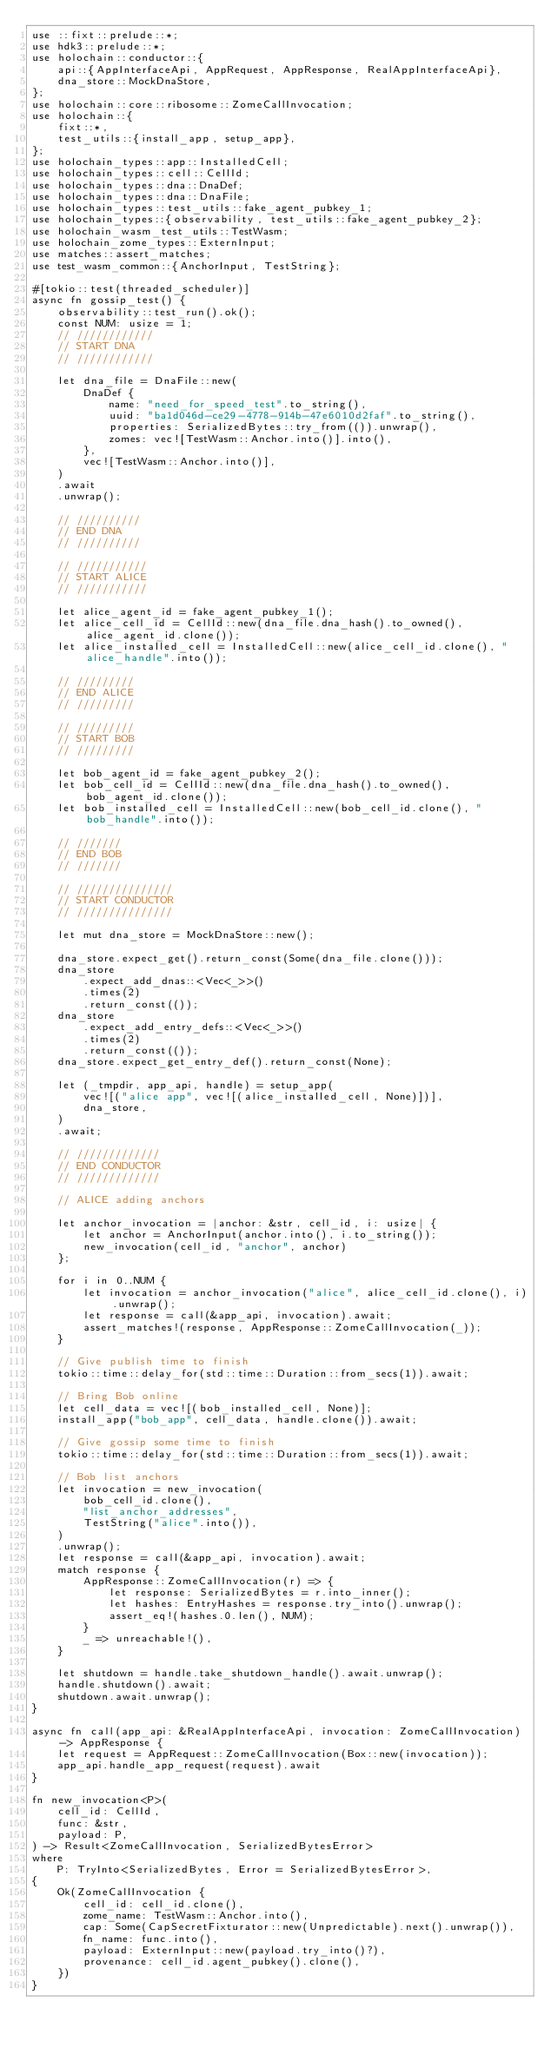<code> <loc_0><loc_0><loc_500><loc_500><_Rust_>use ::fixt::prelude::*;
use hdk3::prelude::*;
use holochain::conductor::{
    api::{AppInterfaceApi, AppRequest, AppResponse, RealAppInterfaceApi},
    dna_store::MockDnaStore,
};
use holochain::core::ribosome::ZomeCallInvocation;
use holochain::{
    fixt::*,
    test_utils::{install_app, setup_app},
};
use holochain_types::app::InstalledCell;
use holochain_types::cell::CellId;
use holochain_types::dna::DnaDef;
use holochain_types::dna::DnaFile;
use holochain_types::test_utils::fake_agent_pubkey_1;
use holochain_types::{observability, test_utils::fake_agent_pubkey_2};
use holochain_wasm_test_utils::TestWasm;
use holochain_zome_types::ExternInput;
use matches::assert_matches;
use test_wasm_common::{AnchorInput, TestString};

#[tokio::test(threaded_scheduler)]
async fn gossip_test() {
    observability::test_run().ok();
    const NUM: usize = 1;
    // ////////////
    // START DNA
    // ////////////

    let dna_file = DnaFile::new(
        DnaDef {
            name: "need_for_speed_test".to_string(),
            uuid: "ba1d046d-ce29-4778-914b-47e6010d2faf".to_string(),
            properties: SerializedBytes::try_from(()).unwrap(),
            zomes: vec![TestWasm::Anchor.into()].into(),
        },
        vec![TestWasm::Anchor.into()],
    )
    .await
    .unwrap();

    // //////////
    // END DNA
    // //////////

    // ///////////
    // START ALICE
    // ///////////

    let alice_agent_id = fake_agent_pubkey_1();
    let alice_cell_id = CellId::new(dna_file.dna_hash().to_owned(), alice_agent_id.clone());
    let alice_installed_cell = InstalledCell::new(alice_cell_id.clone(), "alice_handle".into());

    // /////////
    // END ALICE
    // /////////

    // /////////
    // START BOB
    // /////////

    let bob_agent_id = fake_agent_pubkey_2();
    let bob_cell_id = CellId::new(dna_file.dna_hash().to_owned(), bob_agent_id.clone());
    let bob_installed_cell = InstalledCell::new(bob_cell_id.clone(), "bob_handle".into());

    // ///////
    // END BOB
    // ///////

    // ///////////////
    // START CONDUCTOR
    // ///////////////

    let mut dna_store = MockDnaStore::new();

    dna_store.expect_get().return_const(Some(dna_file.clone()));
    dna_store
        .expect_add_dnas::<Vec<_>>()
        .times(2)
        .return_const(());
    dna_store
        .expect_add_entry_defs::<Vec<_>>()
        .times(2)
        .return_const(());
    dna_store.expect_get_entry_def().return_const(None);

    let (_tmpdir, app_api, handle) = setup_app(
        vec![("alice app", vec![(alice_installed_cell, None)])],
        dna_store,
    )
    .await;

    // /////////////
    // END CONDUCTOR
    // /////////////

    // ALICE adding anchors

    let anchor_invocation = |anchor: &str, cell_id, i: usize| {
        let anchor = AnchorInput(anchor.into(), i.to_string());
        new_invocation(cell_id, "anchor", anchor)
    };

    for i in 0..NUM {
        let invocation = anchor_invocation("alice", alice_cell_id.clone(), i).unwrap();
        let response = call(&app_api, invocation).await;
        assert_matches!(response, AppResponse::ZomeCallInvocation(_));
    }

    // Give publish time to finish
    tokio::time::delay_for(std::time::Duration::from_secs(1)).await;

    // Bring Bob online
    let cell_data = vec![(bob_installed_cell, None)];
    install_app("bob_app", cell_data, handle.clone()).await;

    // Give gossip some time to finish
    tokio::time::delay_for(std::time::Duration::from_secs(1)).await;

    // Bob list anchors
    let invocation = new_invocation(
        bob_cell_id.clone(),
        "list_anchor_addresses",
        TestString("alice".into()),
    )
    .unwrap();
    let response = call(&app_api, invocation).await;
    match response {
        AppResponse::ZomeCallInvocation(r) => {
            let response: SerializedBytes = r.into_inner();
            let hashes: EntryHashes = response.try_into().unwrap();
            assert_eq!(hashes.0.len(), NUM);
        }
        _ => unreachable!(),
    }

    let shutdown = handle.take_shutdown_handle().await.unwrap();
    handle.shutdown().await;
    shutdown.await.unwrap();
}

async fn call(app_api: &RealAppInterfaceApi, invocation: ZomeCallInvocation) -> AppResponse {
    let request = AppRequest::ZomeCallInvocation(Box::new(invocation));
    app_api.handle_app_request(request).await
}

fn new_invocation<P>(
    cell_id: CellId,
    func: &str,
    payload: P,
) -> Result<ZomeCallInvocation, SerializedBytesError>
where
    P: TryInto<SerializedBytes, Error = SerializedBytesError>,
{
    Ok(ZomeCallInvocation {
        cell_id: cell_id.clone(),
        zome_name: TestWasm::Anchor.into(),
        cap: Some(CapSecretFixturator::new(Unpredictable).next().unwrap()),
        fn_name: func.into(),
        payload: ExternInput::new(payload.try_into()?),
        provenance: cell_id.agent_pubkey().clone(),
    })
}
</code> 